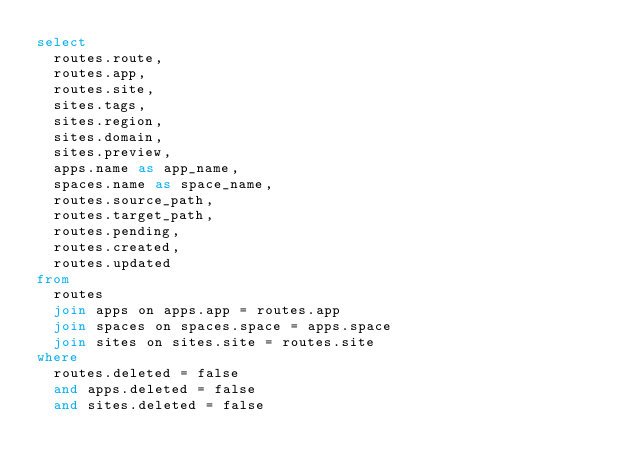Convert code to text. <code><loc_0><loc_0><loc_500><loc_500><_SQL_>select
  routes.route, 
  routes.app, 
  routes.site,
  sites.tags,
  sites.region,
  sites.domain,
  sites.preview,
  apps.name as app_name,
  spaces.name as space_name,
  routes.source_path, 
  routes.target_path, 
  routes.pending,
  routes.created, 
  routes.updated
from
  routes
  join apps on apps.app = routes.app
  join spaces on spaces.space = apps.space
  join sites on sites.site = routes.site
where
  routes.deleted = false
  and apps.deleted = false
  and sites.deleted = false
</code> 